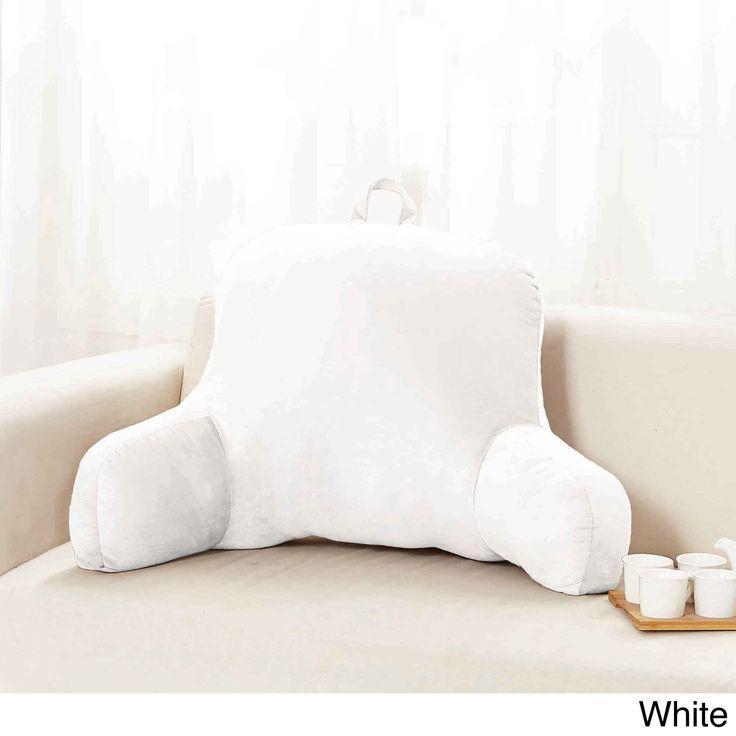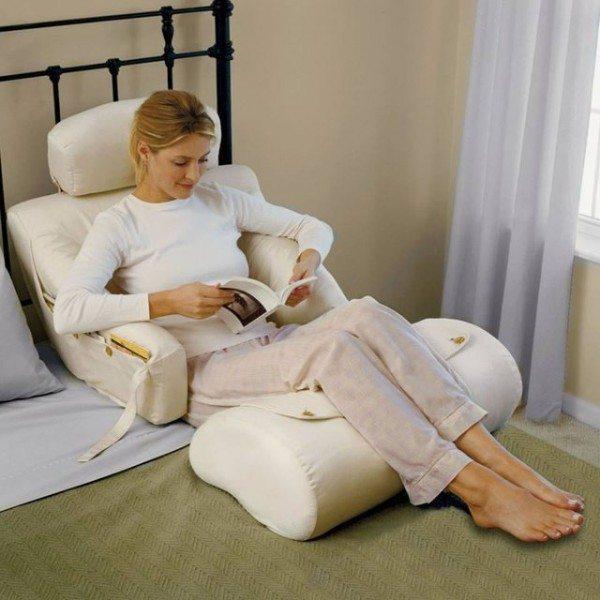The first image is the image on the left, the second image is the image on the right. Analyze the images presented: Is the assertion "One or more images shows a backrest pillow holding a cup in a cup holder on one of the arms along with items in a side pocket" valid? Answer yes or no. No. The first image is the image on the left, the second image is the image on the right. Analyze the images presented: Is the assertion "At least one image features an upright bedrest with a cupholder and pouch in one arm." valid? Answer yes or no. No. 